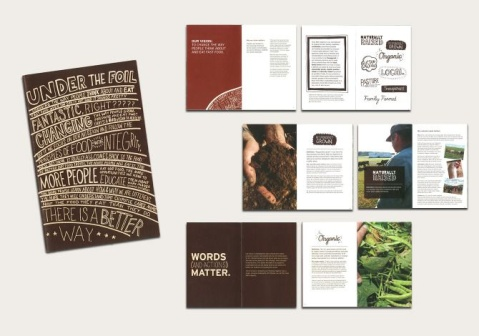What is this photo about'? The image presents a neatly arranged collection of nine printed materials. These materials, which include brochures, flyers, and booklets, are laid out in a grid-like pattern, ensuring that none of them overlap and their relative positions remain consistent.

Each material predominantly features a clean white background, subtly accented with hues of brown and green. The texts inscribed on these materials vary in font and size, adding a dynamic visual element to the overall composition. Among the texts, the phrase "UNDER THE FOIL" and the word "FANT" are prominently visible.

Adding a touch of nature to the design, some of the materials are adorned with images of food and plants. The precise placement of these images enhances the aesthetic appeal of the materials without detracting from the clarity of the information presented.

Overall, the image captures a well-organized display of printed materials, each thoughtfully designed and arranged to provide a harmonious visual experience. The use of color, text, and imagery works together to create an engaging and informative collection. 